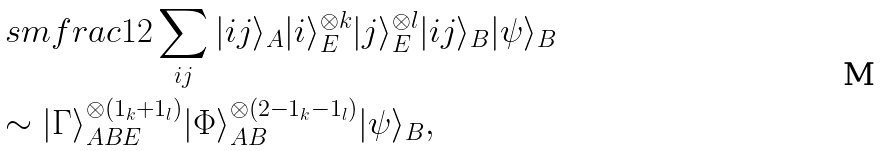<formula> <loc_0><loc_0><loc_500><loc_500>& \ s m f r a c 1 2 \sum _ { i j } | i j \rangle _ { A } | i \rangle _ { E } ^ { \otimes k } | j \rangle _ { E } ^ { \otimes l } | i j \rangle _ { B } | \psi \rangle _ { B } \\ & \sim | \Gamma \rangle _ { A B E } ^ { \otimes ( 1 _ { k } { + } 1 _ { l } ) } | \Phi \rangle _ { A B } ^ { \otimes ( 2 { - } 1 _ { k } { - } 1 _ { l } ) } | \psi \rangle _ { B } ,</formula> 